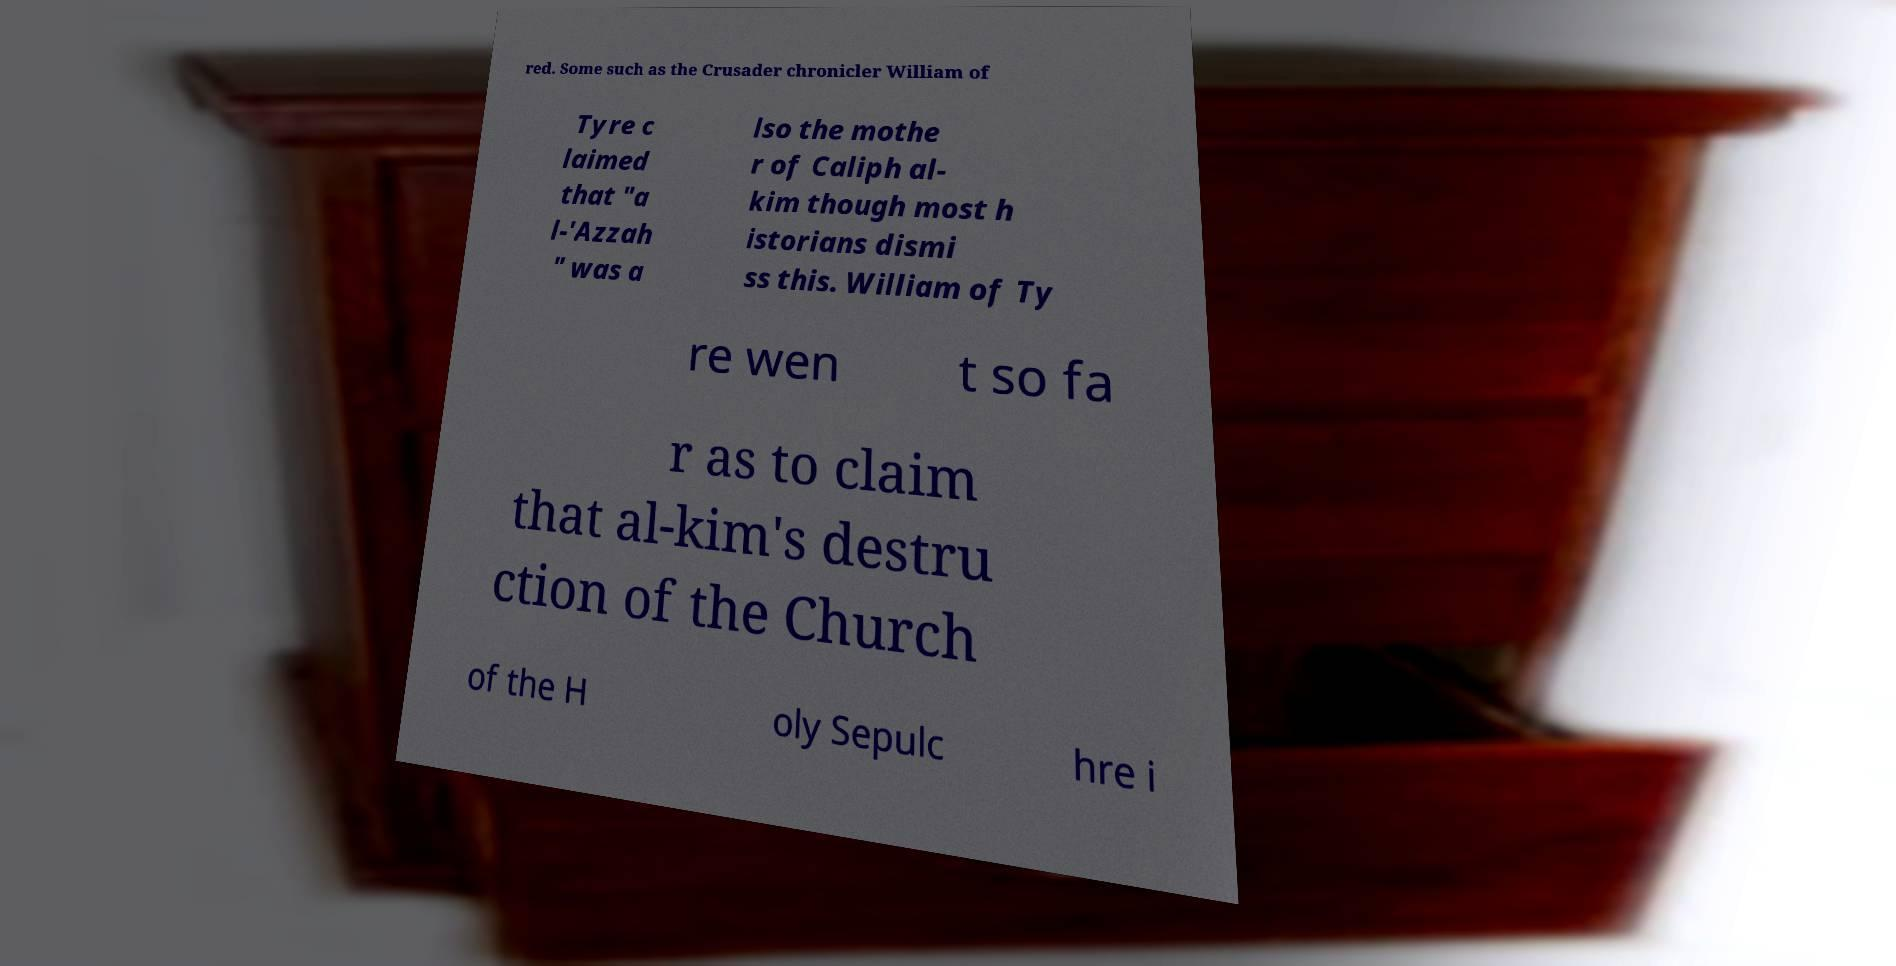Can you accurately transcribe the text from the provided image for me? red. Some such as the Crusader chronicler William of Tyre c laimed that "a l-'Azzah " was a lso the mothe r of Caliph al- kim though most h istorians dismi ss this. William of Ty re wen t so fa r as to claim that al-kim's destru ction of the Church of the H oly Sepulc hre i 